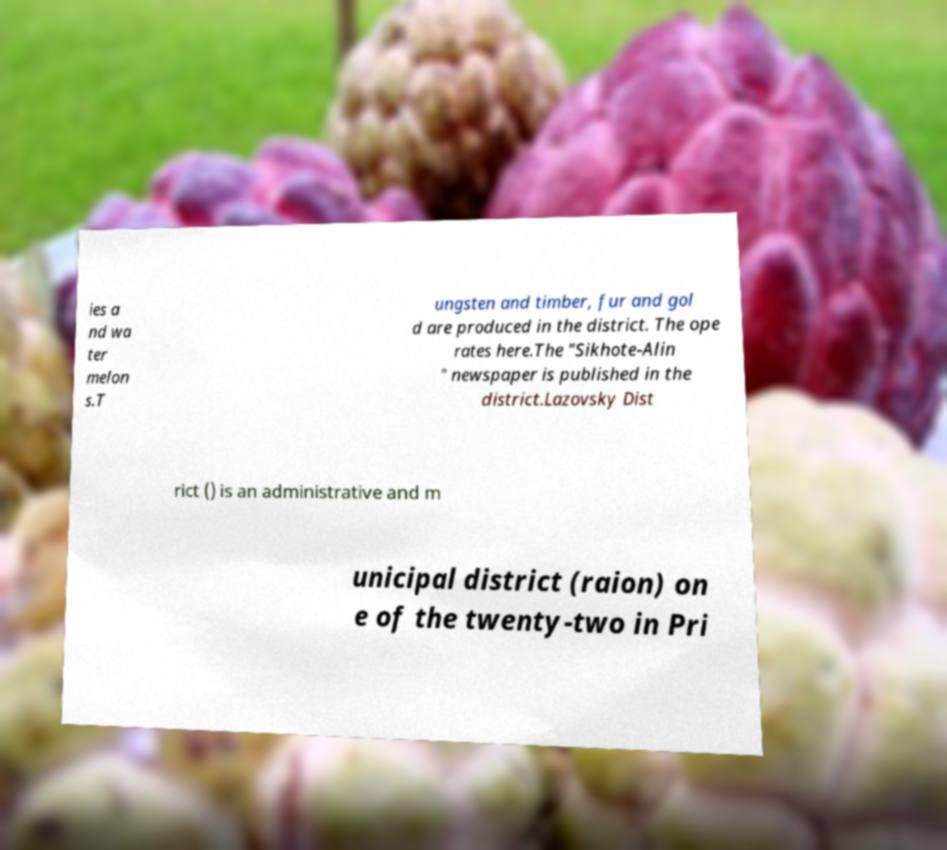Could you assist in decoding the text presented in this image and type it out clearly? ies a nd wa ter melon s.T ungsten and timber, fur and gol d are produced in the district. The ope rates here.The "Sikhote-Alin " newspaper is published in the district.Lazovsky Dist rict () is an administrative and m unicipal district (raion) on e of the twenty-two in Pri 